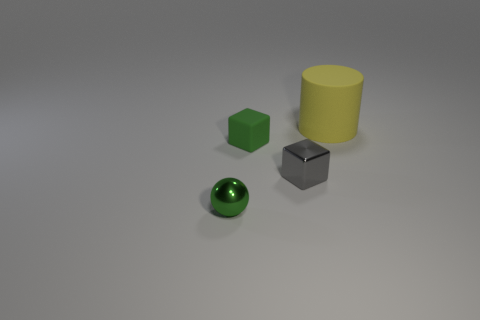What material is the yellow thing?
Provide a short and direct response. Rubber. How many other things are made of the same material as the gray object?
Provide a succinct answer. 1. There is a thing that is both in front of the green block and behind the tiny metallic ball; how big is it?
Make the answer very short. Small. What is the shape of the rubber object that is right of the rubber thing left of the cylinder?
Ensure brevity in your answer.  Cylinder. Is there anything else that has the same shape as the small green metallic thing?
Offer a terse response. No. Are there an equal number of spheres left of the large rubber cylinder and gray rubber objects?
Your answer should be very brief. No. Is the color of the shiny cube the same as the matte thing that is in front of the big yellow rubber thing?
Make the answer very short. No. What is the color of the thing that is both behind the gray object and in front of the big yellow cylinder?
Provide a short and direct response. Green. What number of cubes are to the left of the matte thing in front of the large yellow cylinder?
Make the answer very short. 0. Is there a green matte object that has the same shape as the tiny gray thing?
Ensure brevity in your answer.  Yes. 